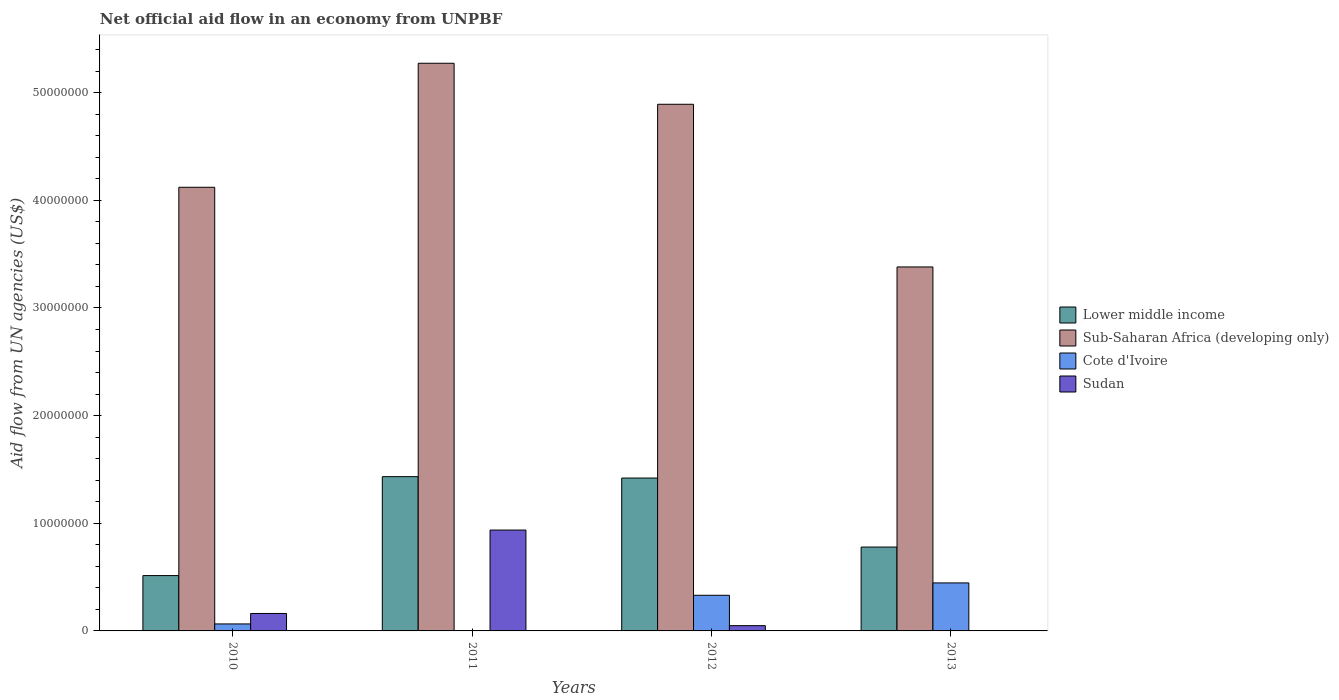How many groups of bars are there?
Make the answer very short. 4. Are the number of bars per tick equal to the number of legend labels?
Ensure brevity in your answer.  No. Are the number of bars on each tick of the X-axis equal?
Give a very brief answer. No. How many bars are there on the 4th tick from the left?
Make the answer very short. 3. What is the label of the 1st group of bars from the left?
Provide a succinct answer. 2010. In how many cases, is the number of bars for a given year not equal to the number of legend labels?
Ensure brevity in your answer.  1. What is the net official aid flow in Sudan in 2011?
Offer a terse response. 9.37e+06. Across all years, what is the maximum net official aid flow in Cote d'Ivoire?
Your answer should be very brief. 4.46e+06. Across all years, what is the minimum net official aid flow in Sudan?
Your response must be concise. 0. What is the total net official aid flow in Cote d'Ivoire in the graph?
Your response must be concise. 8.45e+06. What is the difference between the net official aid flow in Sudan in 2010 and that in 2012?
Give a very brief answer. 1.13e+06. What is the difference between the net official aid flow in Lower middle income in 2010 and the net official aid flow in Cote d'Ivoire in 2013?
Give a very brief answer. 6.80e+05. What is the average net official aid flow in Lower middle income per year?
Offer a very short reply. 1.04e+07. In the year 2012, what is the difference between the net official aid flow in Sudan and net official aid flow in Cote d'Ivoire?
Offer a terse response. -2.82e+06. In how many years, is the net official aid flow in Lower middle income greater than 34000000 US$?
Your answer should be very brief. 0. What is the ratio of the net official aid flow in Sub-Saharan Africa (developing only) in 2010 to that in 2011?
Ensure brevity in your answer.  0.78. Is the difference between the net official aid flow in Sudan in 2011 and 2012 greater than the difference between the net official aid flow in Cote d'Ivoire in 2011 and 2012?
Provide a succinct answer. Yes. What is the difference between the highest and the second highest net official aid flow in Lower middle income?
Ensure brevity in your answer.  1.30e+05. What is the difference between the highest and the lowest net official aid flow in Cote d'Ivoire?
Provide a short and direct response. 4.43e+06. Is it the case that in every year, the sum of the net official aid flow in Cote d'Ivoire and net official aid flow in Sub-Saharan Africa (developing only) is greater than the net official aid flow in Lower middle income?
Offer a very short reply. Yes. How many years are there in the graph?
Ensure brevity in your answer.  4. What is the difference between two consecutive major ticks on the Y-axis?
Offer a terse response. 1.00e+07. Are the values on the major ticks of Y-axis written in scientific E-notation?
Ensure brevity in your answer.  No. Does the graph contain grids?
Offer a terse response. No. Where does the legend appear in the graph?
Keep it short and to the point. Center right. How many legend labels are there?
Your answer should be very brief. 4. What is the title of the graph?
Make the answer very short. Net official aid flow in an economy from UNPBF. What is the label or title of the X-axis?
Your answer should be very brief. Years. What is the label or title of the Y-axis?
Keep it short and to the point. Aid flow from UN agencies (US$). What is the Aid flow from UN agencies (US$) in Lower middle income in 2010?
Give a very brief answer. 5.14e+06. What is the Aid flow from UN agencies (US$) in Sub-Saharan Africa (developing only) in 2010?
Your response must be concise. 4.12e+07. What is the Aid flow from UN agencies (US$) in Cote d'Ivoire in 2010?
Make the answer very short. 6.50e+05. What is the Aid flow from UN agencies (US$) in Sudan in 2010?
Offer a terse response. 1.62e+06. What is the Aid flow from UN agencies (US$) in Lower middle income in 2011?
Offer a very short reply. 1.43e+07. What is the Aid flow from UN agencies (US$) of Sub-Saharan Africa (developing only) in 2011?
Your answer should be compact. 5.27e+07. What is the Aid flow from UN agencies (US$) in Cote d'Ivoire in 2011?
Your response must be concise. 3.00e+04. What is the Aid flow from UN agencies (US$) of Sudan in 2011?
Keep it short and to the point. 9.37e+06. What is the Aid flow from UN agencies (US$) in Lower middle income in 2012?
Keep it short and to the point. 1.42e+07. What is the Aid flow from UN agencies (US$) in Sub-Saharan Africa (developing only) in 2012?
Your answer should be compact. 4.89e+07. What is the Aid flow from UN agencies (US$) in Cote d'Ivoire in 2012?
Your answer should be very brief. 3.31e+06. What is the Aid flow from UN agencies (US$) in Lower middle income in 2013?
Offer a terse response. 7.79e+06. What is the Aid flow from UN agencies (US$) of Sub-Saharan Africa (developing only) in 2013?
Give a very brief answer. 3.38e+07. What is the Aid flow from UN agencies (US$) of Cote d'Ivoire in 2013?
Your answer should be very brief. 4.46e+06. Across all years, what is the maximum Aid flow from UN agencies (US$) in Lower middle income?
Give a very brief answer. 1.43e+07. Across all years, what is the maximum Aid flow from UN agencies (US$) in Sub-Saharan Africa (developing only)?
Your response must be concise. 5.27e+07. Across all years, what is the maximum Aid flow from UN agencies (US$) in Cote d'Ivoire?
Your answer should be very brief. 4.46e+06. Across all years, what is the maximum Aid flow from UN agencies (US$) of Sudan?
Your answer should be compact. 9.37e+06. Across all years, what is the minimum Aid flow from UN agencies (US$) of Lower middle income?
Give a very brief answer. 5.14e+06. Across all years, what is the minimum Aid flow from UN agencies (US$) in Sub-Saharan Africa (developing only)?
Your answer should be very brief. 3.38e+07. Across all years, what is the minimum Aid flow from UN agencies (US$) of Sudan?
Provide a short and direct response. 0. What is the total Aid flow from UN agencies (US$) of Lower middle income in the graph?
Your response must be concise. 4.15e+07. What is the total Aid flow from UN agencies (US$) of Sub-Saharan Africa (developing only) in the graph?
Your answer should be very brief. 1.77e+08. What is the total Aid flow from UN agencies (US$) of Cote d'Ivoire in the graph?
Offer a very short reply. 8.45e+06. What is the total Aid flow from UN agencies (US$) in Sudan in the graph?
Make the answer very short. 1.15e+07. What is the difference between the Aid flow from UN agencies (US$) in Lower middle income in 2010 and that in 2011?
Provide a succinct answer. -9.19e+06. What is the difference between the Aid flow from UN agencies (US$) in Sub-Saharan Africa (developing only) in 2010 and that in 2011?
Offer a very short reply. -1.15e+07. What is the difference between the Aid flow from UN agencies (US$) of Cote d'Ivoire in 2010 and that in 2011?
Keep it short and to the point. 6.20e+05. What is the difference between the Aid flow from UN agencies (US$) in Sudan in 2010 and that in 2011?
Make the answer very short. -7.75e+06. What is the difference between the Aid flow from UN agencies (US$) in Lower middle income in 2010 and that in 2012?
Provide a succinct answer. -9.06e+06. What is the difference between the Aid flow from UN agencies (US$) in Sub-Saharan Africa (developing only) in 2010 and that in 2012?
Your answer should be very brief. -7.71e+06. What is the difference between the Aid flow from UN agencies (US$) of Cote d'Ivoire in 2010 and that in 2012?
Provide a succinct answer. -2.66e+06. What is the difference between the Aid flow from UN agencies (US$) of Sudan in 2010 and that in 2012?
Offer a terse response. 1.13e+06. What is the difference between the Aid flow from UN agencies (US$) in Lower middle income in 2010 and that in 2013?
Provide a short and direct response. -2.65e+06. What is the difference between the Aid flow from UN agencies (US$) of Sub-Saharan Africa (developing only) in 2010 and that in 2013?
Offer a terse response. 7.40e+06. What is the difference between the Aid flow from UN agencies (US$) in Cote d'Ivoire in 2010 and that in 2013?
Give a very brief answer. -3.81e+06. What is the difference between the Aid flow from UN agencies (US$) of Sub-Saharan Africa (developing only) in 2011 and that in 2012?
Ensure brevity in your answer.  3.81e+06. What is the difference between the Aid flow from UN agencies (US$) of Cote d'Ivoire in 2011 and that in 2012?
Give a very brief answer. -3.28e+06. What is the difference between the Aid flow from UN agencies (US$) of Sudan in 2011 and that in 2012?
Offer a terse response. 8.88e+06. What is the difference between the Aid flow from UN agencies (US$) in Lower middle income in 2011 and that in 2013?
Give a very brief answer. 6.54e+06. What is the difference between the Aid flow from UN agencies (US$) of Sub-Saharan Africa (developing only) in 2011 and that in 2013?
Provide a short and direct response. 1.89e+07. What is the difference between the Aid flow from UN agencies (US$) of Cote d'Ivoire in 2011 and that in 2013?
Ensure brevity in your answer.  -4.43e+06. What is the difference between the Aid flow from UN agencies (US$) of Lower middle income in 2012 and that in 2013?
Offer a terse response. 6.41e+06. What is the difference between the Aid flow from UN agencies (US$) in Sub-Saharan Africa (developing only) in 2012 and that in 2013?
Offer a terse response. 1.51e+07. What is the difference between the Aid flow from UN agencies (US$) of Cote d'Ivoire in 2012 and that in 2013?
Offer a terse response. -1.15e+06. What is the difference between the Aid flow from UN agencies (US$) in Lower middle income in 2010 and the Aid flow from UN agencies (US$) in Sub-Saharan Africa (developing only) in 2011?
Ensure brevity in your answer.  -4.76e+07. What is the difference between the Aid flow from UN agencies (US$) in Lower middle income in 2010 and the Aid flow from UN agencies (US$) in Cote d'Ivoire in 2011?
Your answer should be compact. 5.11e+06. What is the difference between the Aid flow from UN agencies (US$) in Lower middle income in 2010 and the Aid flow from UN agencies (US$) in Sudan in 2011?
Give a very brief answer. -4.23e+06. What is the difference between the Aid flow from UN agencies (US$) in Sub-Saharan Africa (developing only) in 2010 and the Aid flow from UN agencies (US$) in Cote d'Ivoire in 2011?
Provide a short and direct response. 4.12e+07. What is the difference between the Aid flow from UN agencies (US$) of Sub-Saharan Africa (developing only) in 2010 and the Aid flow from UN agencies (US$) of Sudan in 2011?
Give a very brief answer. 3.18e+07. What is the difference between the Aid flow from UN agencies (US$) of Cote d'Ivoire in 2010 and the Aid flow from UN agencies (US$) of Sudan in 2011?
Give a very brief answer. -8.72e+06. What is the difference between the Aid flow from UN agencies (US$) of Lower middle income in 2010 and the Aid flow from UN agencies (US$) of Sub-Saharan Africa (developing only) in 2012?
Provide a short and direct response. -4.38e+07. What is the difference between the Aid flow from UN agencies (US$) of Lower middle income in 2010 and the Aid flow from UN agencies (US$) of Cote d'Ivoire in 2012?
Offer a terse response. 1.83e+06. What is the difference between the Aid flow from UN agencies (US$) of Lower middle income in 2010 and the Aid flow from UN agencies (US$) of Sudan in 2012?
Give a very brief answer. 4.65e+06. What is the difference between the Aid flow from UN agencies (US$) in Sub-Saharan Africa (developing only) in 2010 and the Aid flow from UN agencies (US$) in Cote d'Ivoire in 2012?
Your response must be concise. 3.79e+07. What is the difference between the Aid flow from UN agencies (US$) of Sub-Saharan Africa (developing only) in 2010 and the Aid flow from UN agencies (US$) of Sudan in 2012?
Give a very brief answer. 4.07e+07. What is the difference between the Aid flow from UN agencies (US$) of Lower middle income in 2010 and the Aid flow from UN agencies (US$) of Sub-Saharan Africa (developing only) in 2013?
Provide a succinct answer. -2.87e+07. What is the difference between the Aid flow from UN agencies (US$) in Lower middle income in 2010 and the Aid flow from UN agencies (US$) in Cote d'Ivoire in 2013?
Your response must be concise. 6.80e+05. What is the difference between the Aid flow from UN agencies (US$) in Sub-Saharan Africa (developing only) in 2010 and the Aid flow from UN agencies (US$) in Cote d'Ivoire in 2013?
Provide a short and direct response. 3.68e+07. What is the difference between the Aid flow from UN agencies (US$) in Lower middle income in 2011 and the Aid flow from UN agencies (US$) in Sub-Saharan Africa (developing only) in 2012?
Offer a very short reply. -3.46e+07. What is the difference between the Aid flow from UN agencies (US$) in Lower middle income in 2011 and the Aid flow from UN agencies (US$) in Cote d'Ivoire in 2012?
Offer a terse response. 1.10e+07. What is the difference between the Aid flow from UN agencies (US$) of Lower middle income in 2011 and the Aid flow from UN agencies (US$) of Sudan in 2012?
Your response must be concise. 1.38e+07. What is the difference between the Aid flow from UN agencies (US$) in Sub-Saharan Africa (developing only) in 2011 and the Aid flow from UN agencies (US$) in Cote d'Ivoire in 2012?
Provide a succinct answer. 4.94e+07. What is the difference between the Aid flow from UN agencies (US$) in Sub-Saharan Africa (developing only) in 2011 and the Aid flow from UN agencies (US$) in Sudan in 2012?
Your answer should be compact. 5.22e+07. What is the difference between the Aid flow from UN agencies (US$) in Cote d'Ivoire in 2011 and the Aid flow from UN agencies (US$) in Sudan in 2012?
Provide a short and direct response. -4.60e+05. What is the difference between the Aid flow from UN agencies (US$) of Lower middle income in 2011 and the Aid flow from UN agencies (US$) of Sub-Saharan Africa (developing only) in 2013?
Offer a terse response. -1.95e+07. What is the difference between the Aid flow from UN agencies (US$) in Lower middle income in 2011 and the Aid flow from UN agencies (US$) in Cote d'Ivoire in 2013?
Ensure brevity in your answer.  9.87e+06. What is the difference between the Aid flow from UN agencies (US$) in Sub-Saharan Africa (developing only) in 2011 and the Aid flow from UN agencies (US$) in Cote d'Ivoire in 2013?
Keep it short and to the point. 4.83e+07. What is the difference between the Aid flow from UN agencies (US$) of Lower middle income in 2012 and the Aid flow from UN agencies (US$) of Sub-Saharan Africa (developing only) in 2013?
Keep it short and to the point. -1.96e+07. What is the difference between the Aid flow from UN agencies (US$) of Lower middle income in 2012 and the Aid flow from UN agencies (US$) of Cote d'Ivoire in 2013?
Keep it short and to the point. 9.74e+06. What is the difference between the Aid flow from UN agencies (US$) in Sub-Saharan Africa (developing only) in 2012 and the Aid flow from UN agencies (US$) in Cote d'Ivoire in 2013?
Provide a short and direct response. 4.45e+07. What is the average Aid flow from UN agencies (US$) of Lower middle income per year?
Provide a short and direct response. 1.04e+07. What is the average Aid flow from UN agencies (US$) in Sub-Saharan Africa (developing only) per year?
Keep it short and to the point. 4.42e+07. What is the average Aid flow from UN agencies (US$) in Cote d'Ivoire per year?
Give a very brief answer. 2.11e+06. What is the average Aid flow from UN agencies (US$) in Sudan per year?
Provide a succinct answer. 2.87e+06. In the year 2010, what is the difference between the Aid flow from UN agencies (US$) of Lower middle income and Aid flow from UN agencies (US$) of Sub-Saharan Africa (developing only)?
Provide a short and direct response. -3.61e+07. In the year 2010, what is the difference between the Aid flow from UN agencies (US$) in Lower middle income and Aid flow from UN agencies (US$) in Cote d'Ivoire?
Offer a terse response. 4.49e+06. In the year 2010, what is the difference between the Aid flow from UN agencies (US$) of Lower middle income and Aid flow from UN agencies (US$) of Sudan?
Your response must be concise. 3.52e+06. In the year 2010, what is the difference between the Aid flow from UN agencies (US$) in Sub-Saharan Africa (developing only) and Aid flow from UN agencies (US$) in Cote d'Ivoire?
Keep it short and to the point. 4.06e+07. In the year 2010, what is the difference between the Aid flow from UN agencies (US$) of Sub-Saharan Africa (developing only) and Aid flow from UN agencies (US$) of Sudan?
Ensure brevity in your answer.  3.96e+07. In the year 2010, what is the difference between the Aid flow from UN agencies (US$) in Cote d'Ivoire and Aid flow from UN agencies (US$) in Sudan?
Your answer should be very brief. -9.70e+05. In the year 2011, what is the difference between the Aid flow from UN agencies (US$) in Lower middle income and Aid flow from UN agencies (US$) in Sub-Saharan Africa (developing only)?
Your answer should be compact. -3.84e+07. In the year 2011, what is the difference between the Aid flow from UN agencies (US$) in Lower middle income and Aid flow from UN agencies (US$) in Cote d'Ivoire?
Make the answer very short. 1.43e+07. In the year 2011, what is the difference between the Aid flow from UN agencies (US$) of Lower middle income and Aid flow from UN agencies (US$) of Sudan?
Your answer should be very brief. 4.96e+06. In the year 2011, what is the difference between the Aid flow from UN agencies (US$) of Sub-Saharan Africa (developing only) and Aid flow from UN agencies (US$) of Cote d'Ivoire?
Ensure brevity in your answer.  5.27e+07. In the year 2011, what is the difference between the Aid flow from UN agencies (US$) in Sub-Saharan Africa (developing only) and Aid flow from UN agencies (US$) in Sudan?
Your answer should be compact. 4.34e+07. In the year 2011, what is the difference between the Aid flow from UN agencies (US$) of Cote d'Ivoire and Aid flow from UN agencies (US$) of Sudan?
Ensure brevity in your answer.  -9.34e+06. In the year 2012, what is the difference between the Aid flow from UN agencies (US$) in Lower middle income and Aid flow from UN agencies (US$) in Sub-Saharan Africa (developing only)?
Offer a very short reply. -3.47e+07. In the year 2012, what is the difference between the Aid flow from UN agencies (US$) in Lower middle income and Aid flow from UN agencies (US$) in Cote d'Ivoire?
Offer a terse response. 1.09e+07. In the year 2012, what is the difference between the Aid flow from UN agencies (US$) of Lower middle income and Aid flow from UN agencies (US$) of Sudan?
Your answer should be compact. 1.37e+07. In the year 2012, what is the difference between the Aid flow from UN agencies (US$) of Sub-Saharan Africa (developing only) and Aid flow from UN agencies (US$) of Cote d'Ivoire?
Your answer should be very brief. 4.56e+07. In the year 2012, what is the difference between the Aid flow from UN agencies (US$) in Sub-Saharan Africa (developing only) and Aid flow from UN agencies (US$) in Sudan?
Provide a succinct answer. 4.84e+07. In the year 2012, what is the difference between the Aid flow from UN agencies (US$) of Cote d'Ivoire and Aid flow from UN agencies (US$) of Sudan?
Offer a very short reply. 2.82e+06. In the year 2013, what is the difference between the Aid flow from UN agencies (US$) in Lower middle income and Aid flow from UN agencies (US$) in Sub-Saharan Africa (developing only)?
Provide a short and direct response. -2.60e+07. In the year 2013, what is the difference between the Aid flow from UN agencies (US$) in Lower middle income and Aid flow from UN agencies (US$) in Cote d'Ivoire?
Offer a terse response. 3.33e+06. In the year 2013, what is the difference between the Aid flow from UN agencies (US$) of Sub-Saharan Africa (developing only) and Aid flow from UN agencies (US$) of Cote d'Ivoire?
Ensure brevity in your answer.  2.94e+07. What is the ratio of the Aid flow from UN agencies (US$) in Lower middle income in 2010 to that in 2011?
Your answer should be compact. 0.36. What is the ratio of the Aid flow from UN agencies (US$) of Sub-Saharan Africa (developing only) in 2010 to that in 2011?
Your response must be concise. 0.78. What is the ratio of the Aid flow from UN agencies (US$) in Cote d'Ivoire in 2010 to that in 2011?
Keep it short and to the point. 21.67. What is the ratio of the Aid flow from UN agencies (US$) of Sudan in 2010 to that in 2011?
Offer a very short reply. 0.17. What is the ratio of the Aid flow from UN agencies (US$) in Lower middle income in 2010 to that in 2012?
Provide a short and direct response. 0.36. What is the ratio of the Aid flow from UN agencies (US$) in Sub-Saharan Africa (developing only) in 2010 to that in 2012?
Give a very brief answer. 0.84. What is the ratio of the Aid flow from UN agencies (US$) of Cote d'Ivoire in 2010 to that in 2012?
Provide a short and direct response. 0.2. What is the ratio of the Aid flow from UN agencies (US$) in Sudan in 2010 to that in 2012?
Provide a succinct answer. 3.31. What is the ratio of the Aid flow from UN agencies (US$) of Lower middle income in 2010 to that in 2013?
Offer a very short reply. 0.66. What is the ratio of the Aid flow from UN agencies (US$) of Sub-Saharan Africa (developing only) in 2010 to that in 2013?
Ensure brevity in your answer.  1.22. What is the ratio of the Aid flow from UN agencies (US$) in Cote d'Ivoire in 2010 to that in 2013?
Give a very brief answer. 0.15. What is the ratio of the Aid flow from UN agencies (US$) in Lower middle income in 2011 to that in 2012?
Keep it short and to the point. 1.01. What is the ratio of the Aid flow from UN agencies (US$) of Sub-Saharan Africa (developing only) in 2011 to that in 2012?
Provide a succinct answer. 1.08. What is the ratio of the Aid flow from UN agencies (US$) in Cote d'Ivoire in 2011 to that in 2012?
Keep it short and to the point. 0.01. What is the ratio of the Aid flow from UN agencies (US$) of Sudan in 2011 to that in 2012?
Your answer should be compact. 19.12. What is the ratio of the Aid flow from UN agencies (US$) of Lower middle income in 2011 to that in 2013?
Keep it short and to the point. 1.84. What is the ratio of the Aid flow from UN agencies (US$) of Sub-Saharan Africa (developing only) in 2011 to that in 2013?
Keep it short and to the point. 1.56. What is the ratio of the Aid flow from UN agencies (US$) of Cote d'Ivoire in 2011 to that in 2013?
Ensure brevity in your answer.  0.01. What is the ratio of the Aid flow from UN agencies (US$) in Lower middle income in 2012 to that in 2013?
Provide a short and direct response. 1.82. What is the ratio of the Aid flow from UN agencies (US$) in Sub-Saharan Africa (developing only) in 2012 to that in 2013?
Provide a short and direct response. 1.45. What is the ratio of the Aid flow from UN agencies (US$) in Cote d'Ivoire in 2012 to that in 2013?
Keep it short and to the point. 0.74. What is the difference between the highest and the second highest Aid flow from UN agencies (US$) of Sub-Saharan Africa (developing only)?
Provide a succinct answer. 3.81e+06. What is the difference between the highest and the second highest Aid flow from UN agencies (US$) of Cote d'Ivoire?
Your answer should be compact. 1.15e+06. What is the difference between the highest and the second highest Aid flow from UN agencies (US$) of Sudan?
Offer a terse response. 7.75e+06. What is the difference between the highest and the lowest Aid flow from UN agencies (US$) of Lower middle income?
Provide a short and direct response. 9.19e+06. What is the difference between the highest and the lowest Aid flow from UN agencies (US$) of Sub-Saharan Africa (developing only)?
Offer a very short reply. 1.89e+07. What is the difference between the highest and the lowest Aid flow from UN agencies (US$) in Cote d'Ivoire?
Ensure brevity in your answer.  4.43e+06. What is the difference between the highest and the lowest Aid flow from UN agencies (US$) of Sudan?
Offer a terse response. 9.37e+06. 